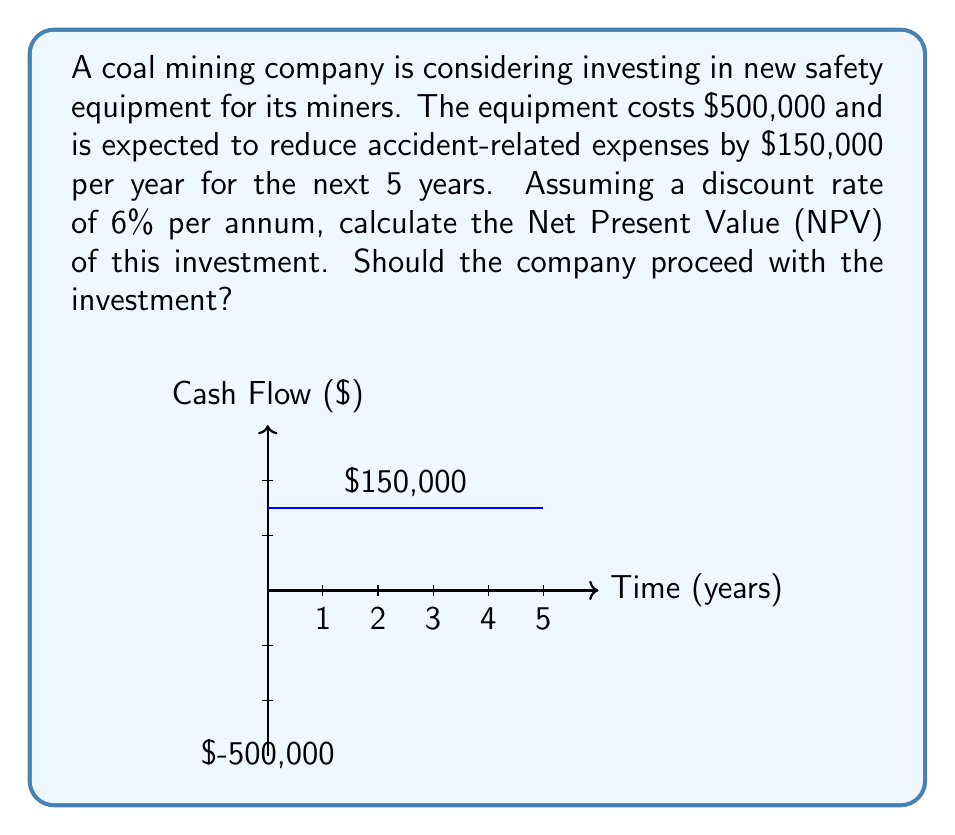Solve this math problem. To solve this problem, we need to calculate the Net Present Value (NPV) of the investment. The NPV is the sum of the present values of all cash flows, including the initial investment.

Step 1: Calculate the present value of the cost savings for each year.
The present value (PV) of each year's savings is given by:

$$ PV = \frac{CF}{(1+r)^t} $$

Where:
CF = Cash Flow ($150,000)
r = Discount rate (6% = 0.06)
t = Time (years 1 to 5)

Year 1: $PV_1 = \frac{150000}{(1+0.06)^1} = 141509.43$
Year 2: $PV_2 = \frac{150000}{(1+0.06)^2} = 133499.47$
Year 3: $PV_3 = \frac{150000}{(1+0.06)^3} = 125943.84$
Year 4: $PV_4 = \frac{150000}{(1+0.06)^4} = 118814.94$
Year 5: $PV_5 = \frac{150000}{(1+0.06)^5} = 112089.57$

Step 2: Sum up all the present values.
$\sum PV = 141509.43 + 133499.47 + 125943.84 + 118814.94 + 112089.57 = 631857.25$

Step 3: Calculate the NPV by subtracting the initial investment from the sum of present values.
$NPV = \sum PV - \text{Initial Investment}$
$NPV = 631857.25 - 500000 = 131857.25$

Since the NPV is positive, the investment is considered financially viable.
Answer: $131,857.25; Yes, invest. 